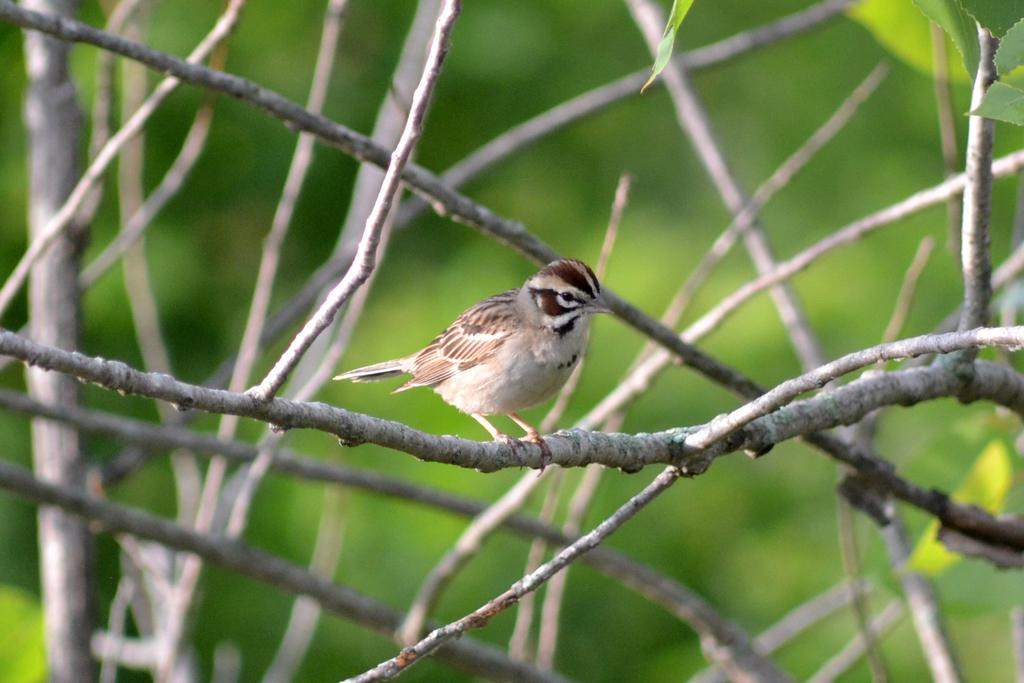What type of animal can be seen in the image? There is a bird in the image. Where is the bird located? The bird is on a branch. What can be observed about the background of the image? The background of the image is blurred. What type of environment is visible in the background? There is greenery in the background of the image. What type of shoes can be seen in the image? There are no shoes present in the image; it features a bird on a branch with a blurred background and greenery. 